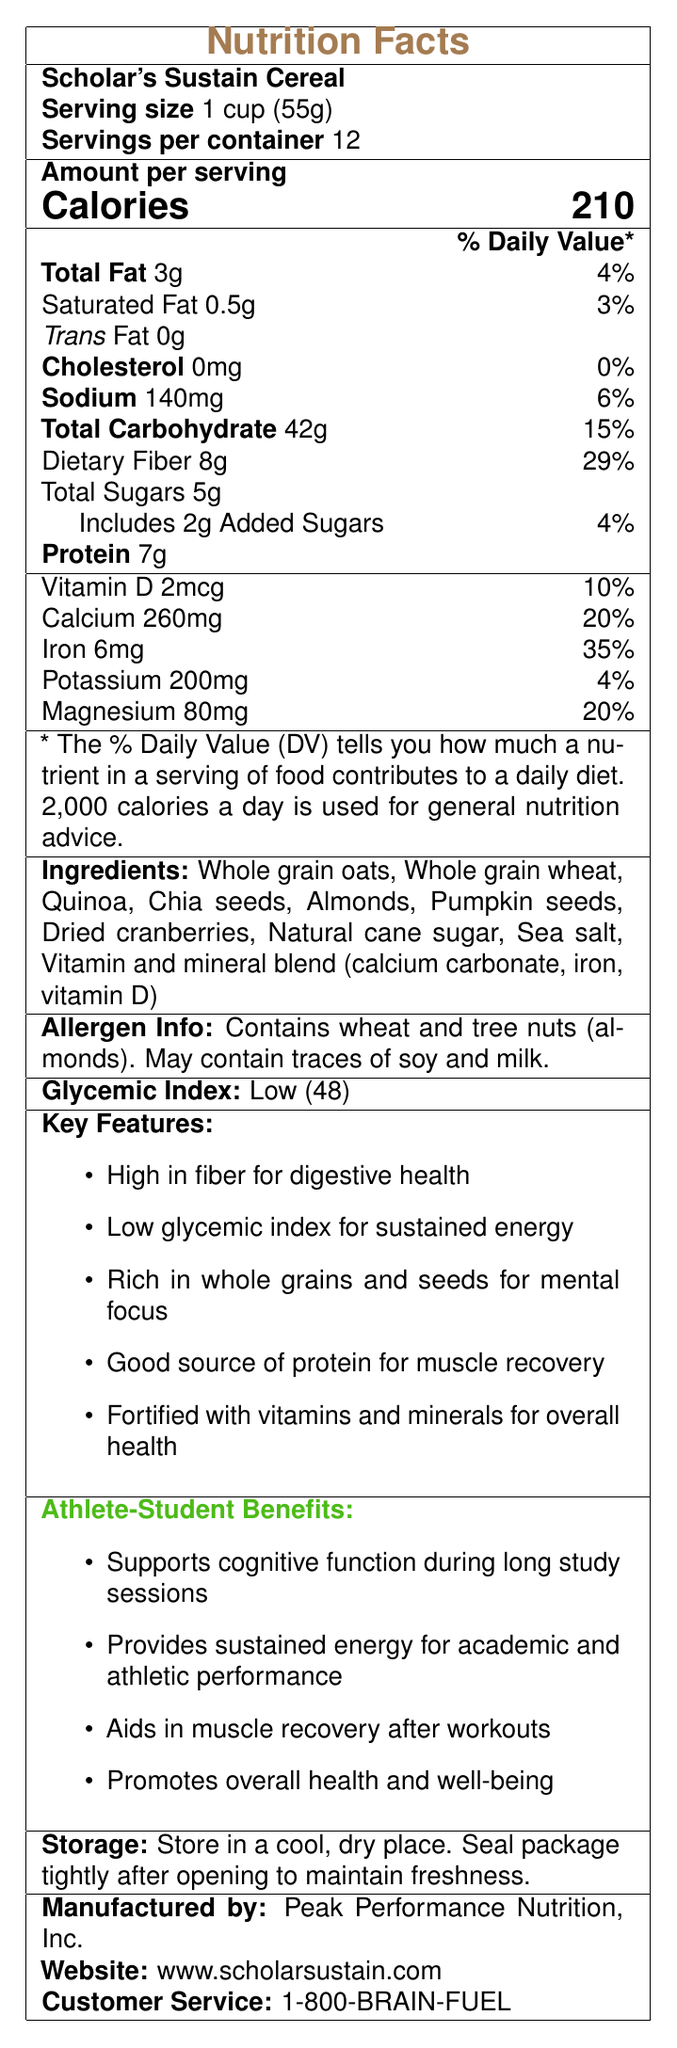what is the serving size? The serving size is explicitly mentioned as "1 cup (55g)" in the document.
Answer: 1 cup (55g) how many calories are in one serving? The document states "Calories: 210" for one serving.
Answer: 210 how much dietary fiber is in one serving? The document states "Dietary Fiber: 8g" in the nutrition facts section.
Answer: 8g does the cereal contain any cholesterol? The document lists "Cholesterol: 0mg" indicating there is no cholesterol in the cereal.
Answer: No what are the ingredients of the cereal? The ingredients are listed in a specific section in the document.
Answer: Whole grain oats, Whole grain wheat, Quinoa, Chia seeds, Almonds, Pumpkin seeds, Dried cranberries, Natural cane sugar, Sea salt, Vitamin and mineral blend (calcium carbonate, iron, vitamin D) which vitamins and minerals are included in the fortification of the cereal? A. Vitamin C and Zinc B. Vitamin D and Calcium C. Iron and Vitamin A D. Vitamin B12 and Magnesium The document lists a vitamin and mineral blend that includes calcium carbonate and vitamin D.
Answer: B. Vitamin D and Calcium how much added sugar does the cereal contain? A. 0g B. 1g C. 2g D. 5g The document states "Includes 2g Added Sugars."
Answer: C. 2g how many servings are in one container? A. 10 B. 12 C. 15 D. 20 The document states "Servings per container: 12."
Answer: B. 12 is the product suitable for someone with a tree nut allergy? The document states that the cereal contains tree nuts (almonds).
Answer: No does the cereal support muscle recovery after workouts? The document mentions that the protein content in the cereal aids in muscle recovery after workouts.
Answer: Yes describe the main idea of the document This summary captures the core aspects of the cereal’s nutritional profile, health benefits, target audience, and additional product details provided in the document.
Answer: The document provides detailed nutritional information about Scholar's Sustain Cereal, highlighting its low glycemic index, high fiber content, and suitability for sustained energy during long study sessions. It lists all the ingredients, key features, and health benefits specifically for student-athletes. Additionally, it includes allergen information, storage instructions, and manufacturer details. what is the cereal's glycemic index value? The glycemic index value is specifically mentioned as "Low (48)" in the document.
Answer: 48 what is the daily value percentage for iron in one serving? The document lists the daily value for iron as "35%."
Answer: 35% how should the cereal be stored after opening? The document specifies storage instructions under the "Storage" section.
Answer: Seal package tightly and store in a cool, dry place what is the name of the manufacturer? A. Nutrient Hub, Inc. B. Peak Performance Nutrition, Inc. C. Health and Wellness Ltd. D. Active Life Foods The document states "Manufactured by: Peak Performance Nutrition, Inc."
Answer: B. Peak Performance Nutrition, Inc. will the cereal provide enough potassium to meet 20% of the daily value? The document lists the potassium content as 200mg, which is 4% of the daily value.
Answer: No is the cereal gluten-free? The document lists wheat as an ingredient, but does not specify if it is gluten-free or if the wheat is processed to remove gluten.
Answer: Not enough information what are the key features of the cereal? The document provides a section labeled "Key Features" which lists all these points.
Answer: 1. High in fiber for digestive health 
2. Low glycemic index for sustained energy 
3. Rich in whole grains and seeds for mental focus 
4. Good source of protein for muscle recovery 
5. Fortified with vitamins and minerals for overall health 